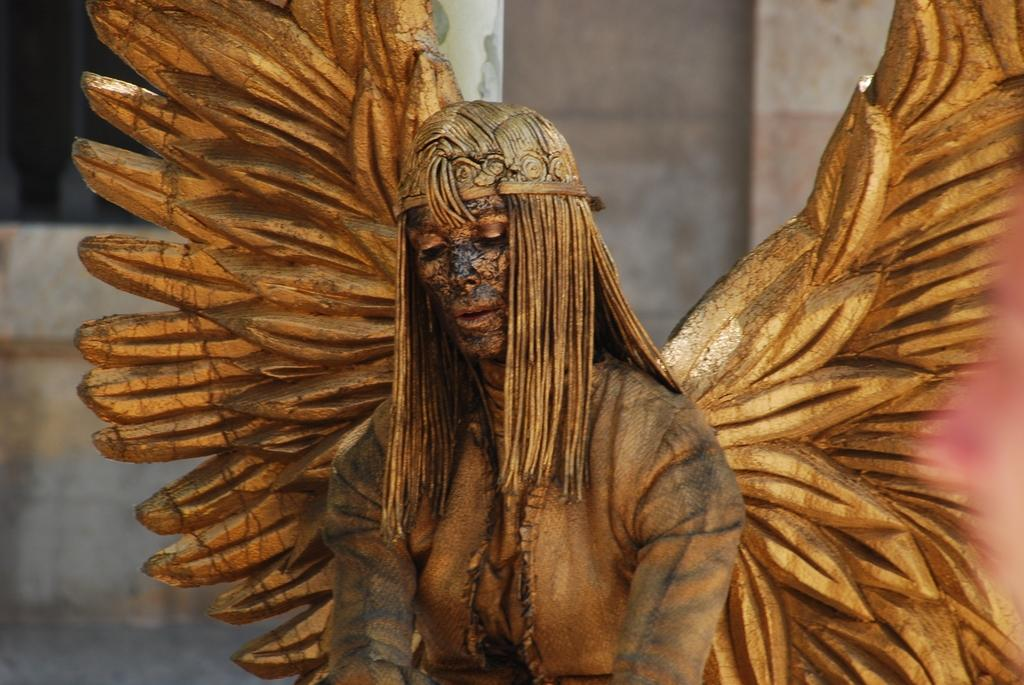Who or what is the main subject of the image? There is a person in the image. What is the person wearing? The person is wearing a fancy dress. Can you describe the background of the image? The background of the image is blurred. How many socks can be seen on the person's feet in the image? There is no information about socks or the person's feet in the image, so it cannot be determined. 